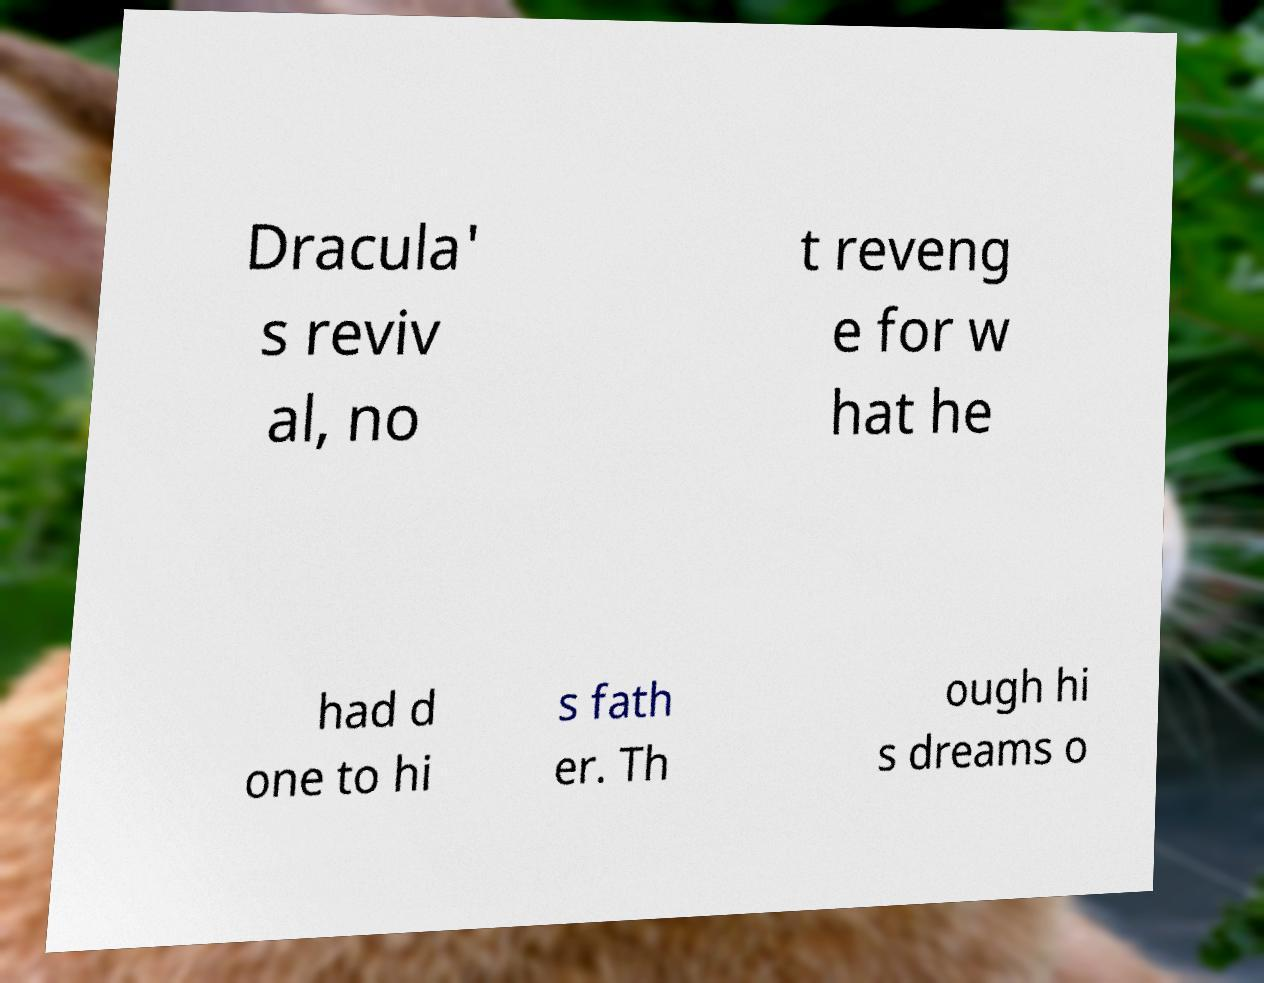Can you accurately transcribe the text from the provided image for me? Dracula' s reviv al, no t reveng e for w hat he had d one to hi s fath er. Th ough hi s dreams o 